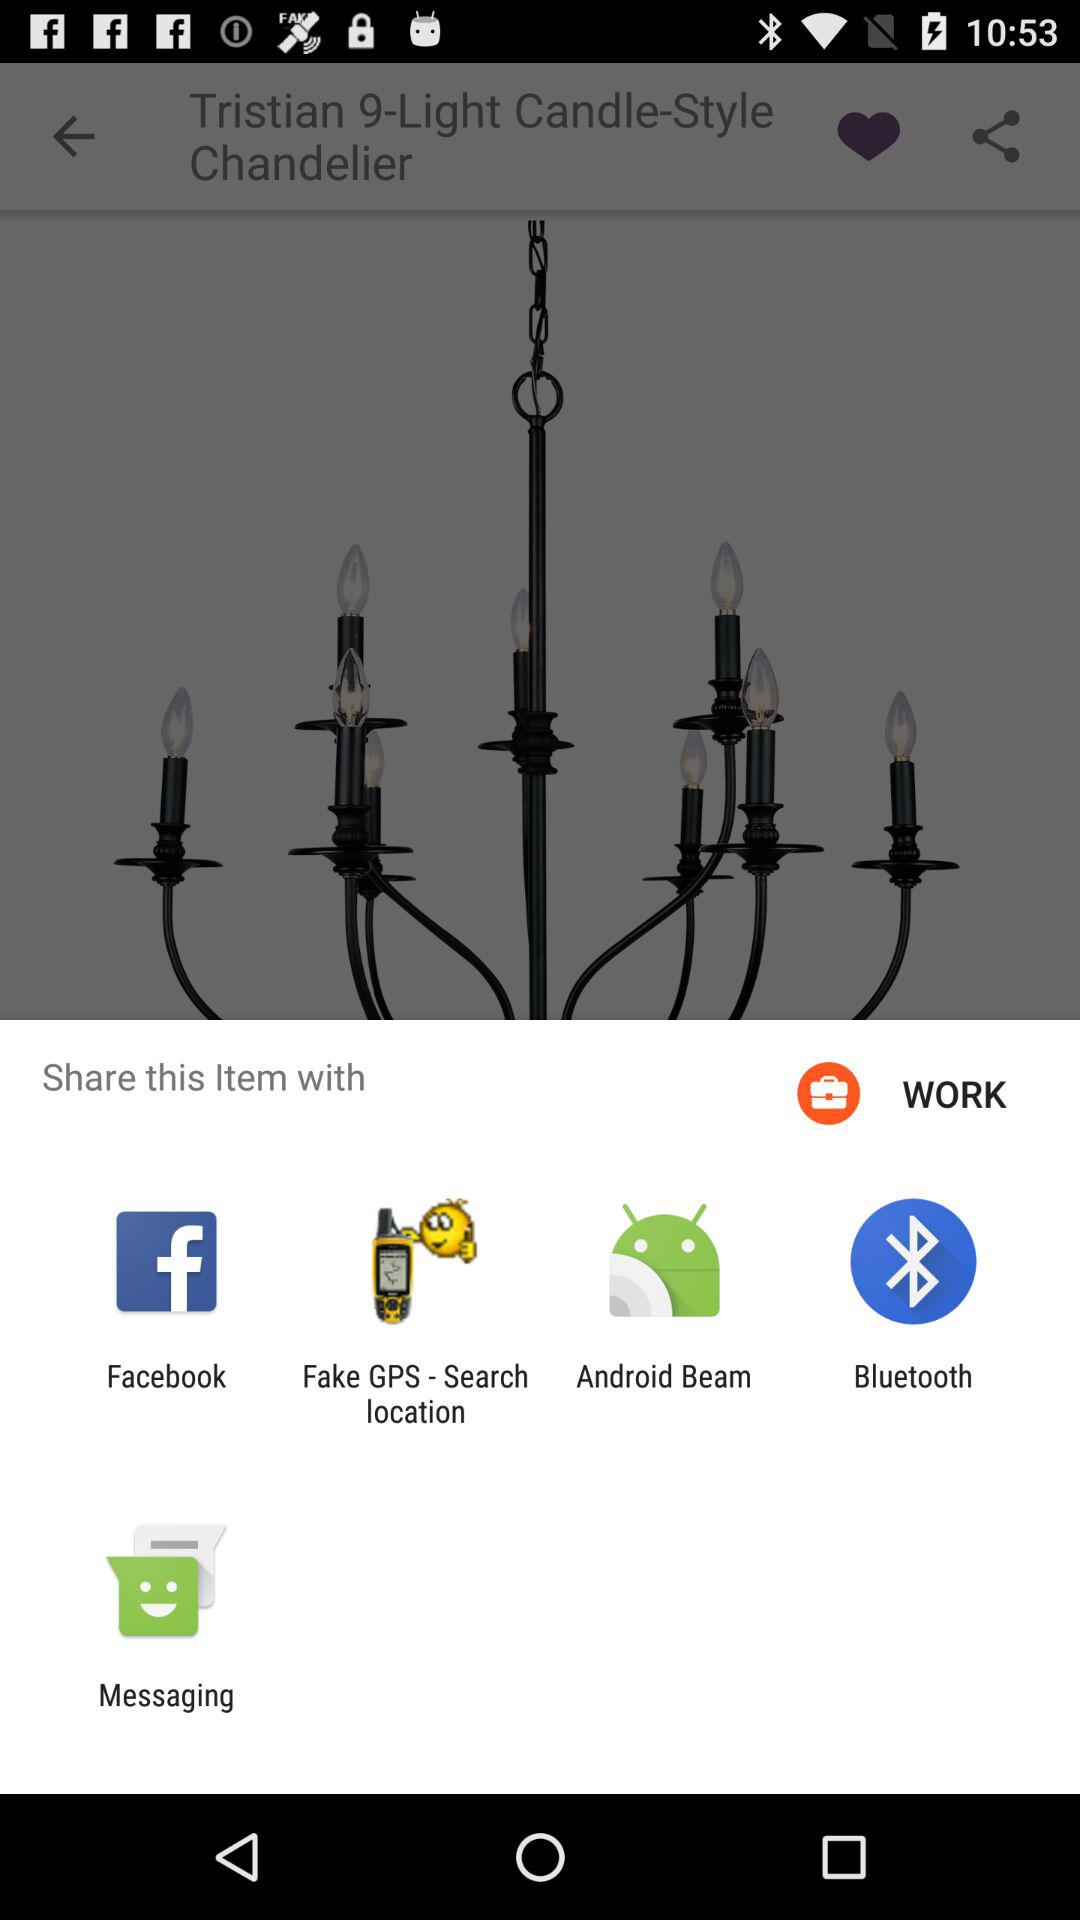Which options are given to share the item with? The options are "Facebook", "Fake GPS - Search location", "Android Beam", "Bluetooth" and "Messaging". 